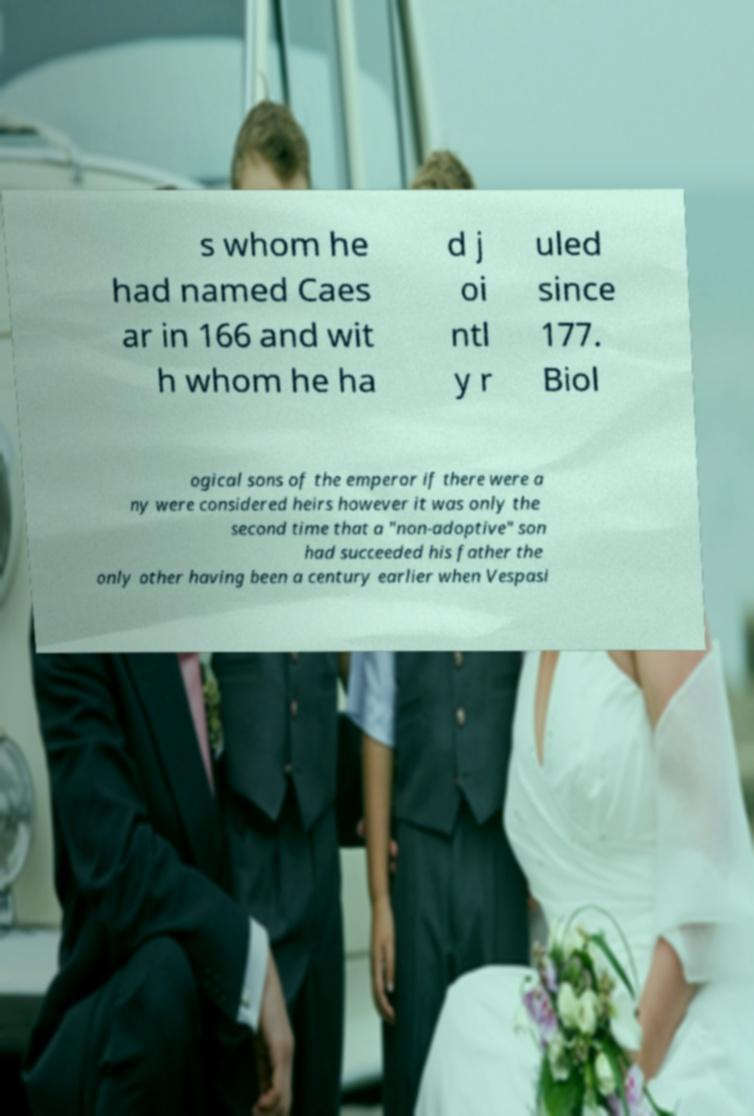Could you extract and type out the text from this image? s whom he had named Caes ar in 166 and wit h whom he ha d j oi ntl y r uled since 177. Biol ogical sons of the emperor if there were a ny were considered heirs however it was only the second time that a "non-adoptive" son had succeeded his father the only other having been a century earlier when Vespasi 